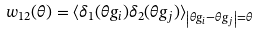<formula> <loc_0><loc_0><loc_500><loc_500>w _ { 1 2 } ( \theta ) = \langle \delta _ { 1 } ( \theta g _ { i } ) \delta _ { 2 } ( \theta g _ { j } ) \rangle _ { \left | \theta g _ { i } - \theta g _ { j } \right | = \theta }</formula> 